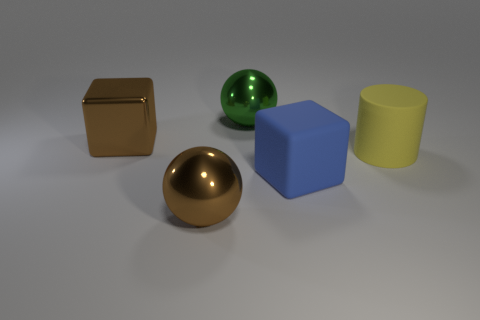Add 3 large green shiny balls. How many objects exist? 8 Subtract all balls. How many objects are left? 3 Subtract 0 red balls. How many objects are left? 5 Subtract all large purple matte balls. Subtract all metallic cubes. How many objects are left? 4 Add 4 shiny spheres. How many shiny spheres are left? 6 Add 3 small brown cylinders. How many small brown cylinders exist? 3 